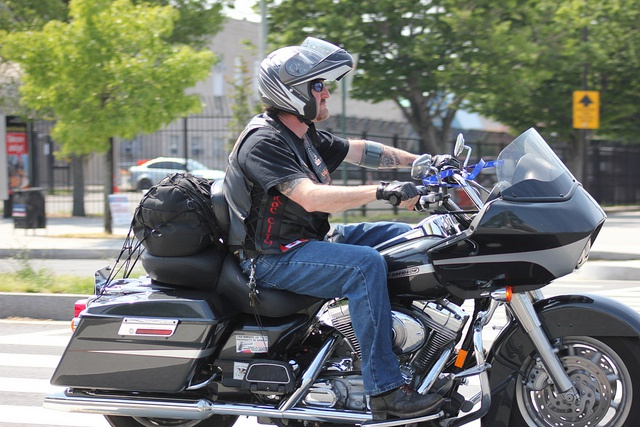Describe the objects in this image and their specific colors. I can see motorcycle in olive, black, gray, darkgray, and lightgray tones, people in gray, black, darkblue, and darkgray tones, backpack in olive, black, gray, and darkgray tones, and car in gray, white, and darkgray tones in this image. 